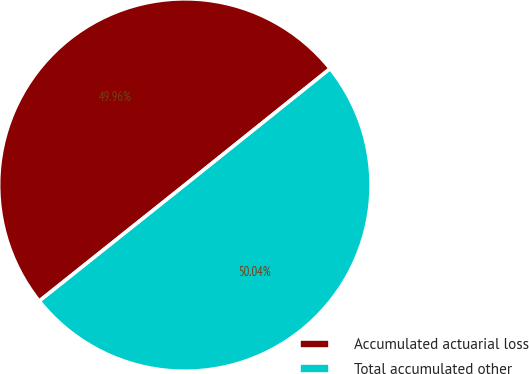Convert chart to OTSL. <chart><loc_0><loc_0><loc_500><loc_500><pie_chart><fcel>Accumulated actuarial loss<fcel>Total accumulated other<nl><fcel>49.96%<fcel>50.04%<nl></chart> 